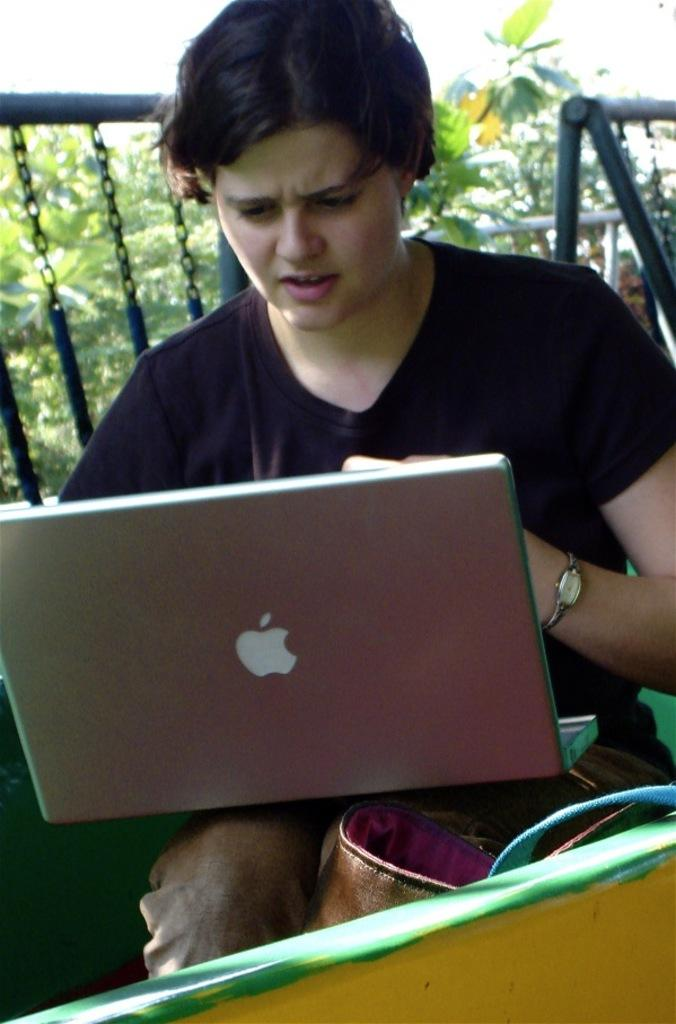What is the main subject of the image? There is a woman in the image. What is the woman doing in the image? The woman is working with a laptop. What can be seen in the background of the image? There is a fence in the background of the image, and behind the fence, there are trees. What color are the fairies flying around the woman in the image? There are no fairies present in the image, so we cannot determine their color. 